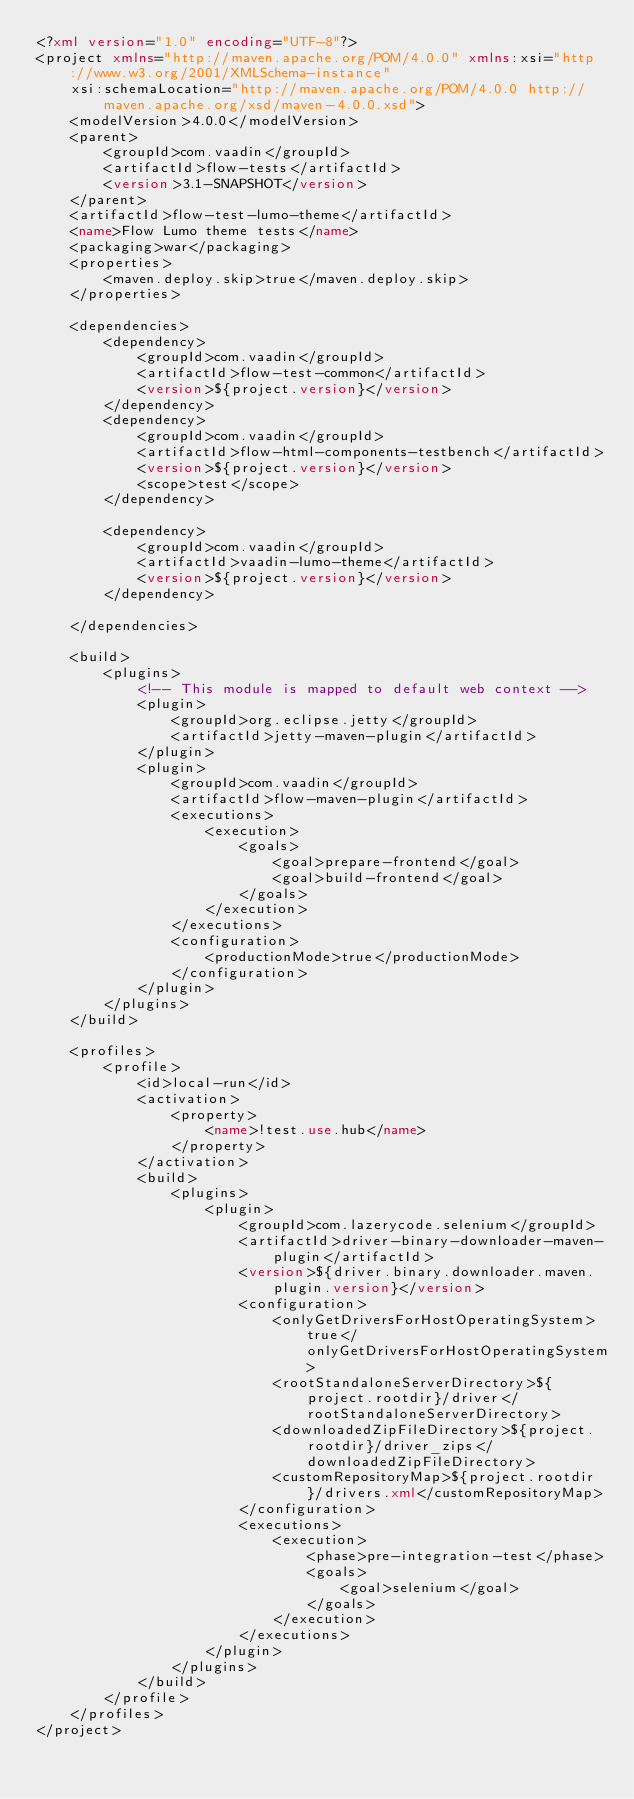<code> <loc_0><loc_0><loc_500><loc_500><_XML_><?xml version="1.0" encoding="UTF-8"?>
<project xmlns="http://maven.apache.org/POM/4.0.0" xmlns:xsi="http://www.w3.org/2001/XMLSchema-instance"
    xsi:schemaLocation="http://maven.apache.org/POM/4.0.0 http://maven.apache.org/xsd/maven-4.0.0.xsd">
    <modelVersion>4.0.0</modelVersion>
    <parent>
        <groupId>com.vaadin</groupId>
        <artifactId>flow-tests</artifactId>
        <version>3.1-SNAPSHOT</version>
    </parent>
    <artifactId>flow-test-lumo-theme</artifactId>
    <name>Flow Lumo theme tests</name>
    <packaging>war</packaging>
    <properties>
        <maven.deploy.skip>true</maven.deploy.skip>
    </properties>

    <dependencies>
        <dependency>
            <groupId>com.vaadin</groupId>
            <artifactId>flow-test-common</artifactId>
            <version>${project.version}</version>
        </dependency>
        <dependency>
            <groupId>com.vaadin</groupId>
            <artifactId>flow-html-components-testbench</artifactId>
            <version>${project.version}</version>
            <scope>test</scope>
        </dependency>

        <dependency>
            <groupId>com.vaadin</groupId>
            <artifactId>vaadin-lumo-theme</artifactId>
            <version>${project.version}</version>
        </dependency>

    </dependencies>

    <build>
        <plugins>
            <!-- This module is mapped to default web context -->
            <plugin>
                <groupId>org.eclipse.jetty</groupId>
                <artifactId>jetty-maven-plugin</artifactId>
            </plugin>
            <plugin>
                <groupId>com.vaadin</groupId>
                <artifactId>flow-maven-plugin</artifactId>
                <executions>
                    <execution>
                        <goals>
                            <goal>prepare-frontend</goal>
                            <goal>build-frontend</goal>
                        </goals>
                    </execution>
                </executions>
                <configuration>
                    <productionMode>true</productionMode>
                </configuration>
            </plugin>
        </plugins>
    </build>

    <profiles>
        <profile>
            <id>local-run</id>
            <activation>
                <property>
                    <name>!test.use.hub</name>
                </property>
            </activation>
            <build>
                <plugins>
                    <plugin>
                        <groupId>com.lazerycode.selenium</groupId>
                        <artifactId>driver-binary-downloader-maven-plugin</artifactId>
                        <version>${driver.binary.downloader.maven.plugin.version}</version>
                        <configuration>
                            <onlyGetDriversForHostOperatingSystem>true</onlyGetDriversForHostOperatingSystem>
                            <rootStandaloneServerDirectory>${project.rootdir}/driver</rootStandaloneServerDirectory>
                            <downloadedZipFileDirectory>${project.rootdir}/driver_zips</downloadedZipFileDirectory>
                            <customRepositoryMap>${project.rootdir}/drivers.xml</customRepositoryMap>
                        </configuration>
                        <executions>
                            <execution>
                                <phase>pre-integration-test</phase>
                                <goals>
                                    <goal>selenium</goal>
                                </goals>
                            </execution>
                        </executions>
                    </plugin>
                </plugins>
            </build>
        </profile>
    </profiles>
</project>

</code> 